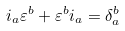<formula> <loc_0><loc_0><loc_500><loc_500>i _ { a } \varepsilon ^ { b } + \varepsilon ^ { b } i _ { a } = \delta _ { a } ^ { b }</formula> 